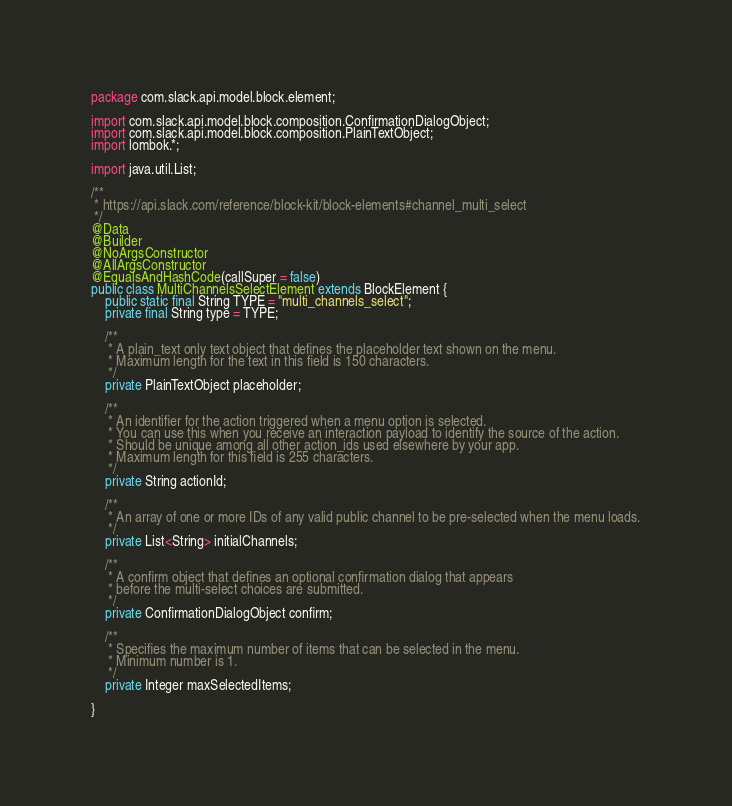Convert code to text. <code><loc_0><loc_0><loc_500><loc_500><_Java_>package com.slack.api.model.block.element;

import com.slack.api.model.block.composition.ConfirmationDialogObject;
import com.slack.api.model.block.composition.PlainTextObject;
import lombok.*;

import java.util.List;

/**
 * https://api.slack.com/reference/block-kit/block-elements#channel_multi_select
 */
@Data
@Builder
@NoArgsConstructor
@AllArgsConstructor
@EqualsAndHashCode(callSuper = false)
public class MultiChannelsSelectElement extends BlockElement {
    public static final String TYPE = "multi_channels_select";
    private final String type = TYPE;

    /**
     * A plain_text only text object that defines the placeholder text shown on the menu.
     * Maximum length for the text in this field is 150 characters.
     */
    private PlainTextObject placeholder;

    /**
     * An identifier for the action triggered when a menu option is selected.
     * You can use this when you receive an interaction payload to identify the source of the action.
     * Should be unique among all other action_ids used elsewhere by your app.
     * Maximum length for this field is 255 characters.
     */
    private String actionId;

    /**
     * An array of one or more IDs of any valid public channel to be pre-selected when the menu loads.
     */
    private List<String> initialChannels;

    /**
     * A confirm object that defines an optional confirmation dialog that appears
     * before the multi-select choices are submitted.
     */
    private ConfirmationDialogObject confirm;

    /**
     * Specifies the maximum number of items that can be selected in the menu.
     * Minimum number is 1.
     */
    private Integer maxSelectedItems;

}
</code> 